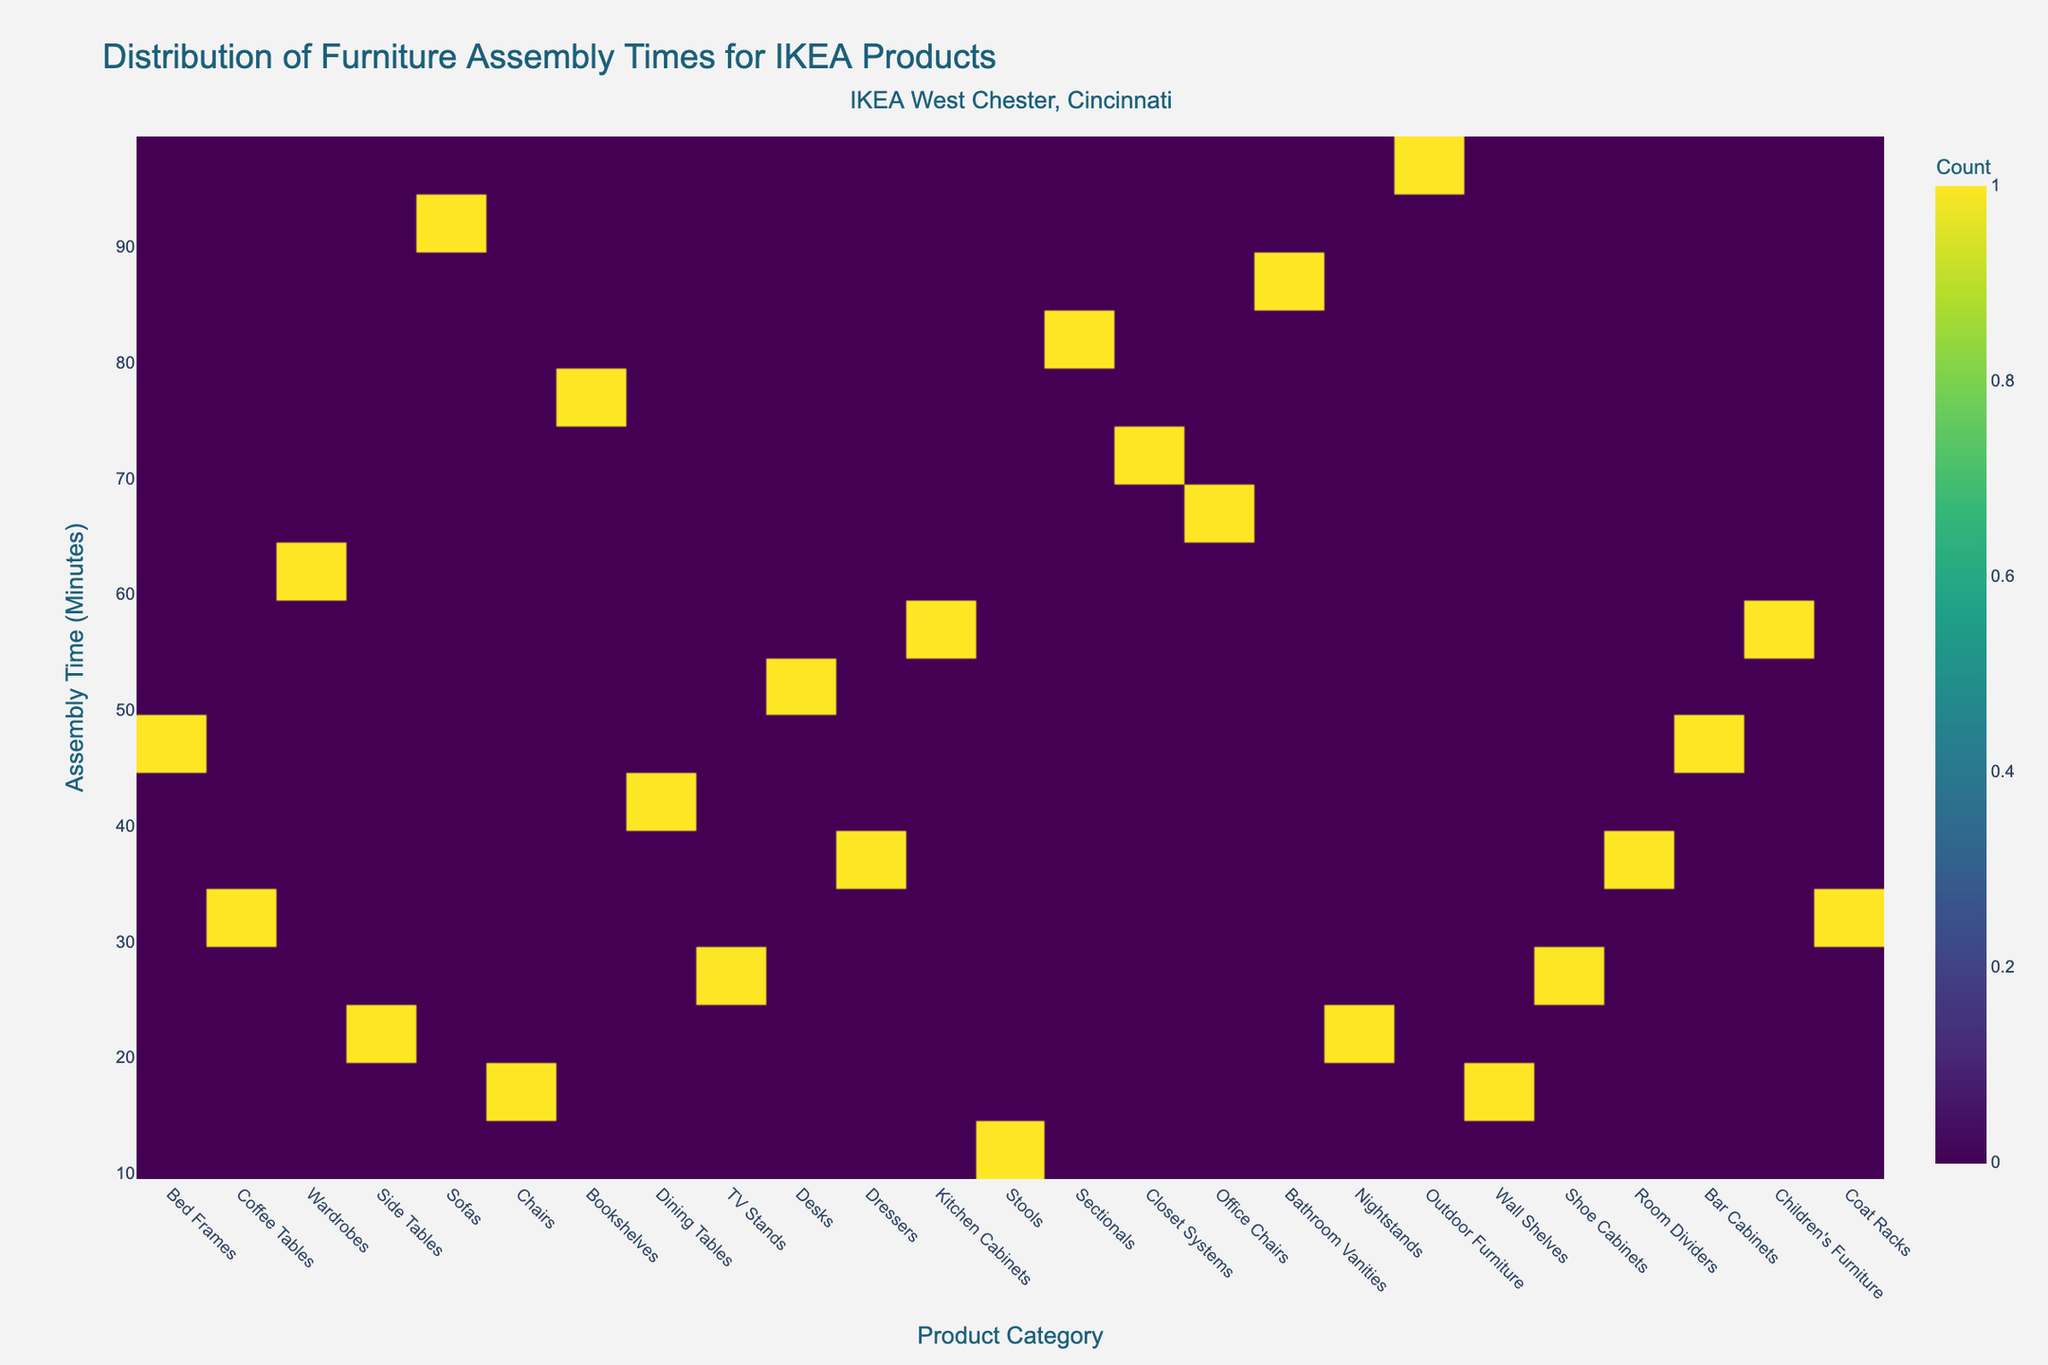What is the title of the figure? The title is usually found at the top of the figure and is directly labeled.
Answer: Distribution of Furniture Assembly Times for IKEA Products Which product category appears to have the longest average assembly time? Observing the y-axis and the density of the plot, the product category with the highest assembly time is identified.
Answer: Outdoor Furniture Which product category has the shortest average assembly time? Similarly, by looking at the lowest end of the y-axis and the density plot, we determine which category it is.
Answer: Stools How does the assembly time of Sofas compare to that of Desks? Locate both product categories on the x-axis and compare their positions on the y-axis where the densities are highest.
Answer: Sofas typically require more assembly time than Desks Can you name two product categories with mid-range assembly times around 40 to 50 minutes? Check along the y-axis around the 40-50 minute range and identify the categories with density clusters.
Answer: Coffee Tables and Dressers What is the overall range of assembly times displayed in the figure? Identify the minimum and maximum points on the y-axis where data is present to determine the range of assembly times.
Answer: 10 to 95 minutes Which product categories have assembly times above 70 minutes? Look above the 70-minute mark on the y-axis and identify any high-density areas for specific product categories.
Answer: Outdoor Furniture, Sectionals, and Bathroom Vanities How does the density of data points differ between Bed Frames and Children's Furniture? Observe the concentration (color intensity) of data points for these two categories to compare their densities.
Answer: Bed Frames have a higher density of assembly times around 45 minutes compared to Children's Furniture around 58 minutes Which product category has assembly times closest to the median of the entire dataset? First, identify the median value (around 45 minutes) and locate the product category with data points clustering around this value.
Answer: Bed Frames Where does Nightstands fall in terms of assembly time compared to Coffee Tables? Locate both product categories on the x-axis and compare their centralized positions on the y-axis.
Answer: Nightstands typically require slightly more assembly time than Coffee Tables 